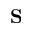<formula> <loc_0><loc_0><loc_500><loc_500>S</formula> 